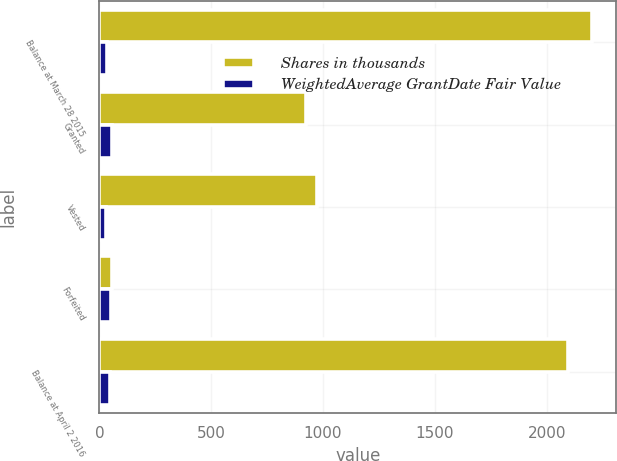Convert chart. <chart><loc_0><loc_0><loc_500><loc_500><stacked_bar_chart><ecel><fcel>Balance at March 28 2015<fcel>Granted<fcel>Vested<fcel>Forfeited<fcel>Balance at April 2 2016<nl><fcel>Shares in thousands<fcel>2202<fcel>923<fcel>972<fcel>58<fcel>2095<nl><fcel>WeightedAverage GrantDate Fair Value<fcel>34.29<fcel>56.65<fcel>27.86<fcel>51.81<fcel>47.09<nl></chart> 